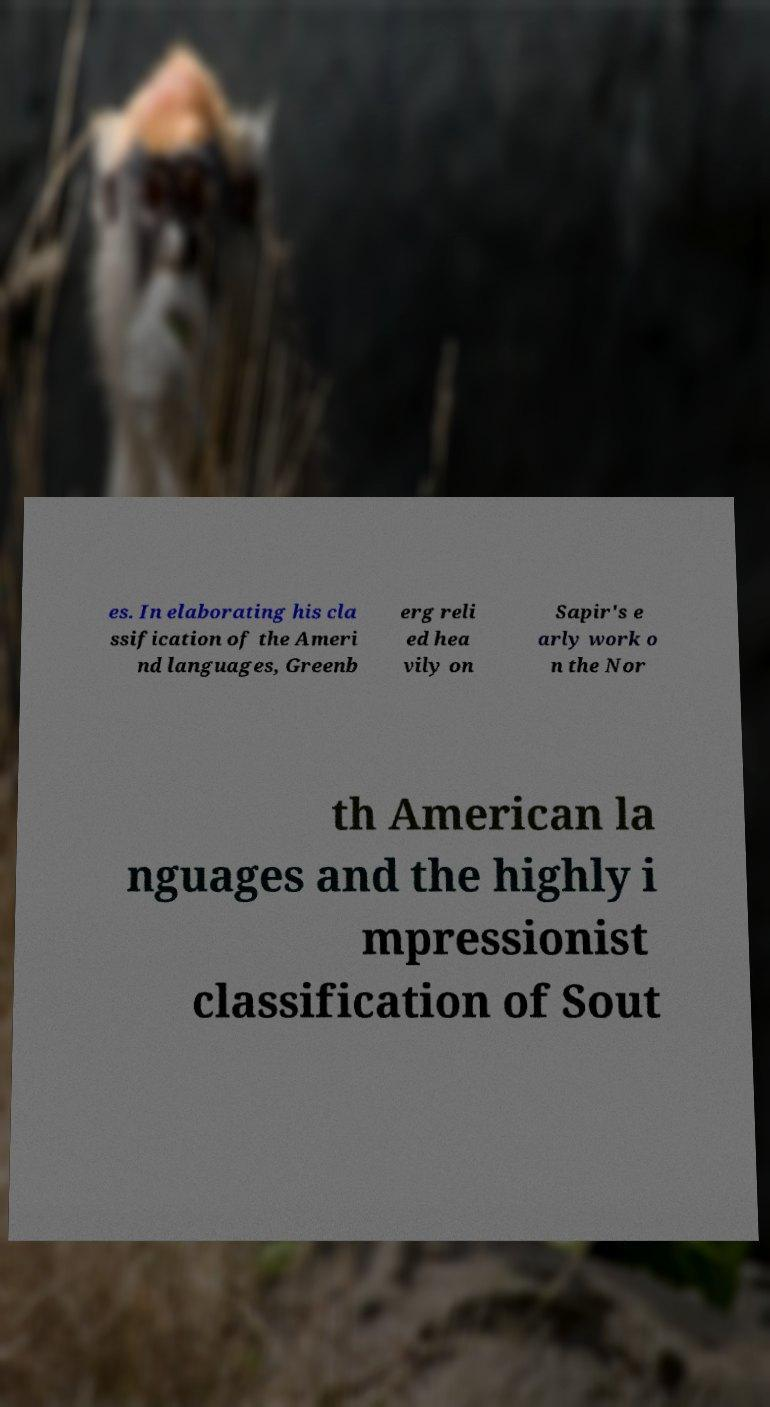Could you extract and type out the text from this image? es. In elaborating his cla ssification of the Ameri nd languages, Greenb erg reli ed hea vily on Sapir's e arly work o n the Nor th American la nguages and the highly i mpressionist classification of Sout 